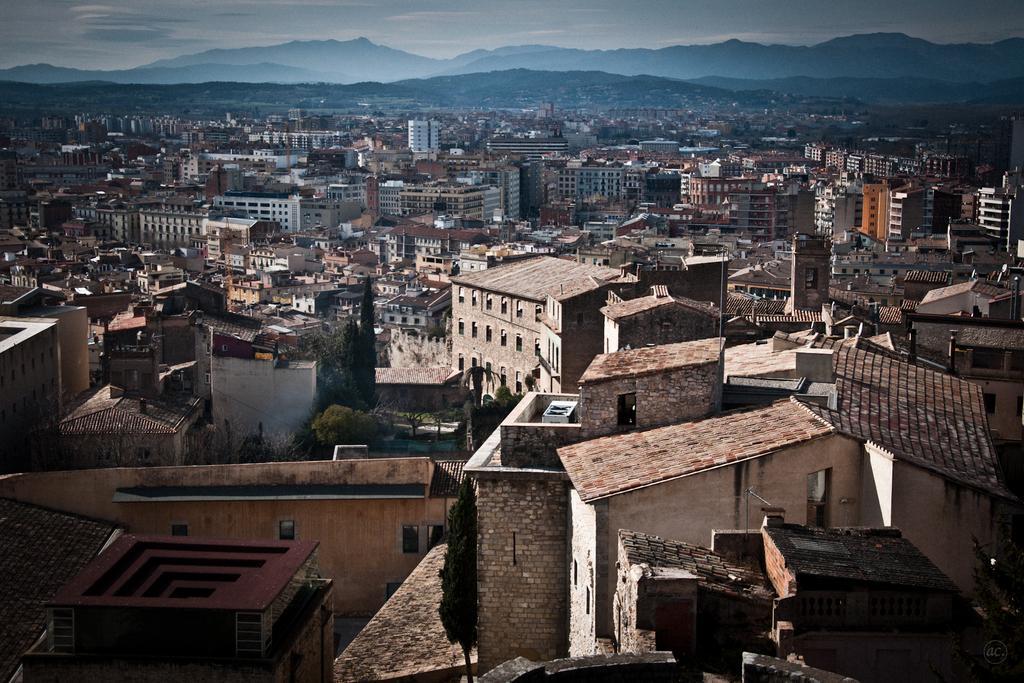In one or two sentences, can you explain what this image depicts? In this picture I can see buildings, trees and hills and I can see a cloudy sky. 